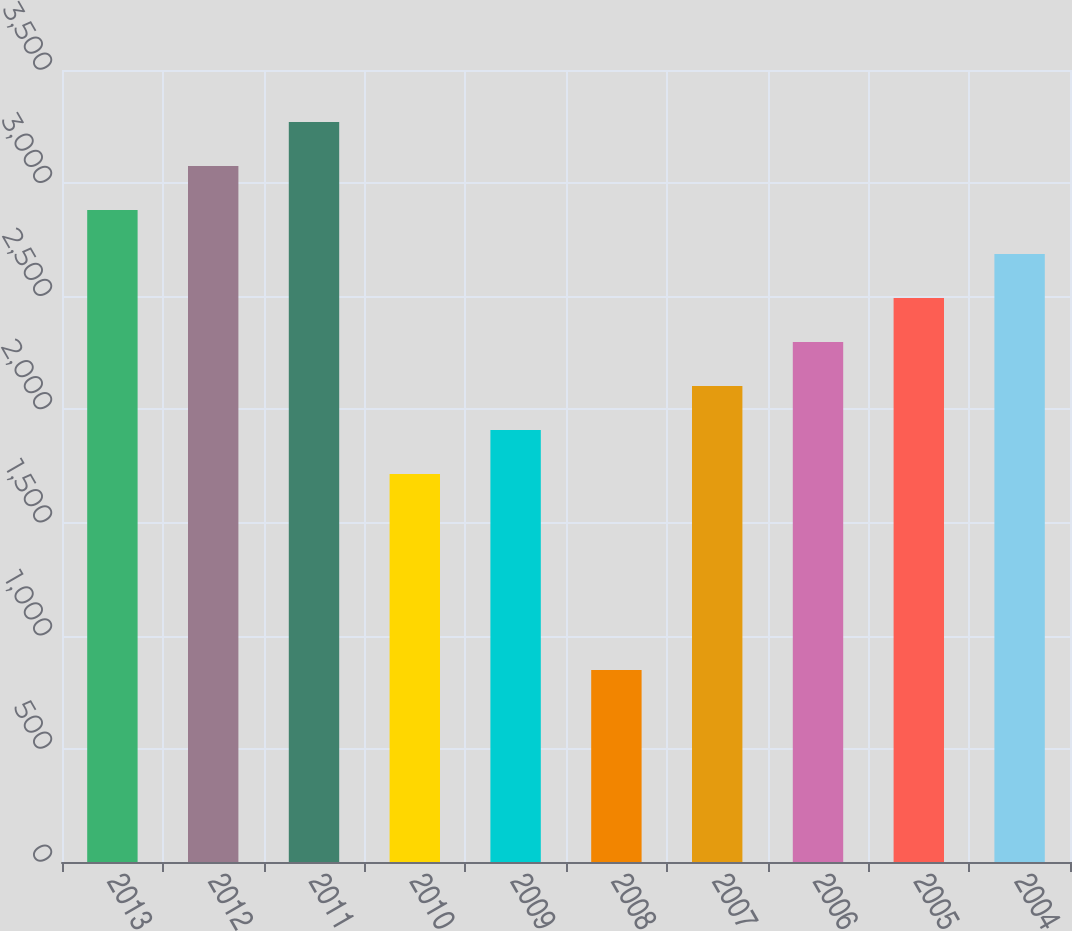<chart> <loc_0><loc_0><loc_500><loc_500><bar_chart><fcel>2013<fcel>2012<fcel>2011<fcel>2010<fcel>2009<fcel>2008<fcel>2007<fcel>2006<fcel>2005<fcel>2004<nl><fcel>2881.4<fcel>3075.8<fcel>3270.2<fcel>1715<fcel>1909.4<fcel>848<fcel>2103.8<fcel>2298.2<fcel>2492.6<fcel>2687<nl></chart> 